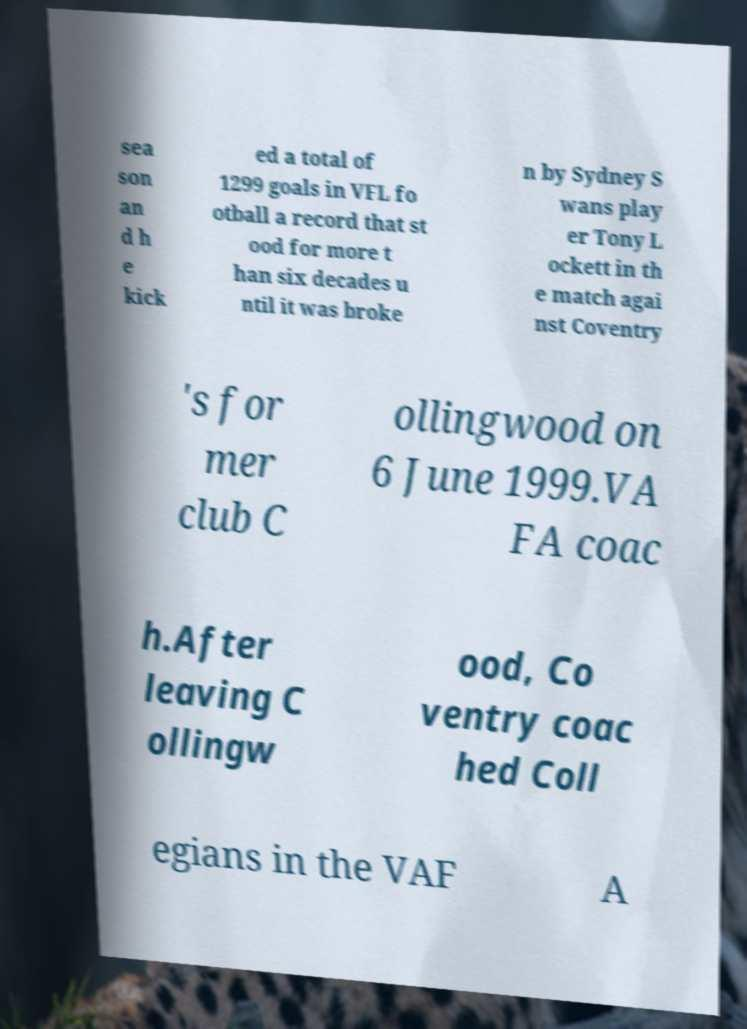Could you assist in decoding the text presented in this image and type it out clearly? sea son an d h e kick ed a total of 1299 goals in VFL fo otball a record that st ood for more t han six decades u ntil it was broke n by Sydney S wans play er Tony L ockett in th e match agai nst Coventry 's for mer club C ollingwood on 6 June 1999.VA FA coac h.After leaving C ollingw ood, Co ventry coac hed Coll egians in the VAF A 